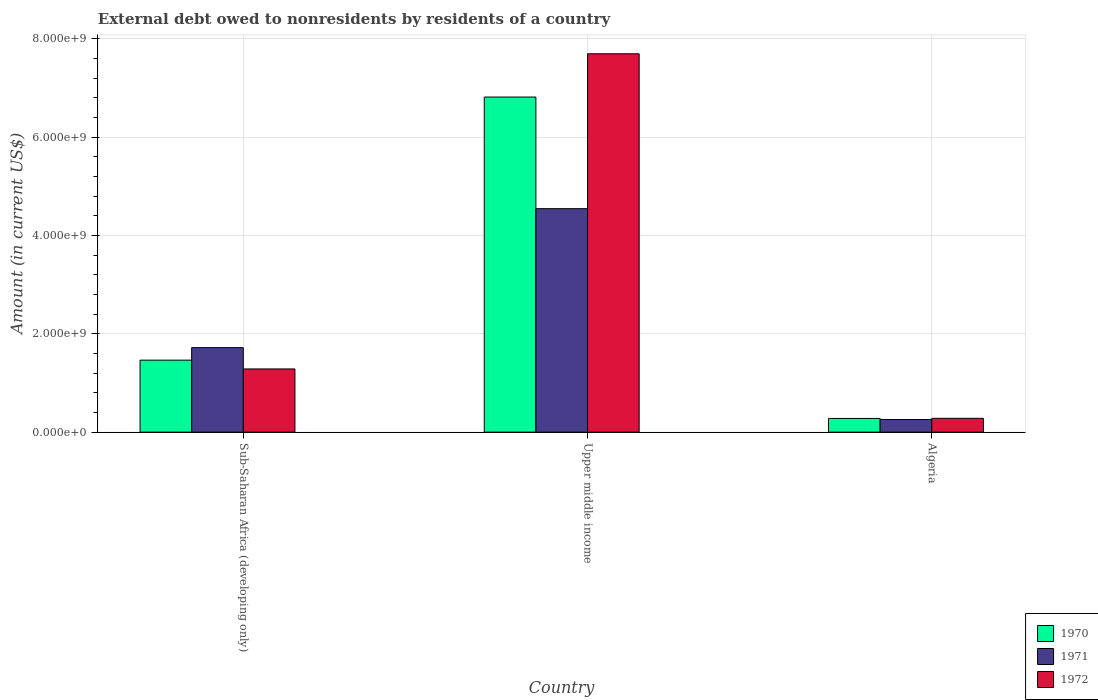How many different coloured bars are there?
Provide a short and direct response. 3. Are the number of bars on each tick of the X-axis equal?
Your answer should be very brief. Yes. What is the label of the 1st group of bars from the left?
Offer a very short reply. Sub-Saharan Africa (developing only). What is the external debt owed by residents in 1970 in Upper middle income?
Make the answer very short. 6.81e+09. Across all countries, what is the maximum external debt owed by residents in 1971?
Ensure brevity in your answer.  4.54e+09. Across all countries, what is the minimum external debt owed by residents in 1971?
Provide a succinct answer. 2.57e+08. In which country was the external debt owed by residents in 1972 maximum?
Offer a terse response. Upper middle income. In which country was the external debt owed by residents in 1972 minimum?
Provide a succinct answer. Algeria. What is the total external debt owed by residents in 1971 in the graph?
Provide a short and direct response. 6.52e+09. What is the difference between the external debt owed by residents in 1972 in Algeria and that in Upper middle income?
Make the answer very short. -7.41e+09. What is the difference between the external debt owed by residents in 1971 in Sub-Saharan Africa (developing only) and the external debt owed by residents in 1970 in Upper middle income?
Your answer should be compact. -5.10e+09. What is the average external debt owed by residents in 1970 per country?
Ensure brevity in your answer.  2.85e+09. What is the difference between the external debt owed by residents of/in 1972 and external debt owed by residents of/in 1970 in Algeria?
Make the answer very short. 2.27e+06. In how many countries, is the external debt owed by residents in 1970 greater than 4400000000 US$?
Keep it short and to the point. 1. What is the ratio of the external debt owed by residents in 1972 in Sub-Saharan Africa (developing only) to that in Upper middle income?
Offer a terse response. 0.17. Is the external debt owed by residents in 1971 in Algeria less than that in Upper middle income?
Provide a succinct answer. Yes. What is the difference between the highest and the second highest external debt owed by residents in 1972?
Make the answer very short. 6.41e+09. What is the difference between the highest and the lowest external debt owed by residents in 1972?
Provide a short and direct response. 7.41e+09. In how many countries, is the external debt owed by residents in 1971 greater than the average external debt owed by residents in 1971 taken over all countries?
Your answer should be very brief. 1. Is the sum of the external debt owed by residents in 1970 in Algeria and Sub-Saharan Africa (developing only) greater than the maximum external debt owed by residents in 1971 across all countries?
Offer a very short reply. No. What does the 2nd bar from the left in Upper middle income represents?
Provide a succinct answer. 1971. What does the 3rd bar from the right in Algeria represents?
Offer a very short reply. 1970. What is the difference between two consecutive major ticks on the Y-axis?
Offer a terse response. 2.00e+09. Are the values on the major ticks of Y-axis written in scientific E-notation?
Offer a very short reply. Yes. Does the graph contain grids?
Provide a short and direct response. Yes. Where does the legend appear in the graph?
Your answer should be compact. Bottom right. How are the legend labels stacked?
Make the answer very short. Vertical. What is the title of the graph?
Your answer should be compact. External debt owed to nonresidents by residents of a country. What is the label or title of the Y-axis?
Your answer should be compact. Amount (in current US$). What is the Amount (in current US$) in 1970 in Sub-Saharan Africa (developing only)?
Your response must be concise. 1.46e+09. What is the Amount (in current US$) in 1971 in Sub-Saharan Africa (developing only)?
Keep it short and to the point. 1.72e+09. What is the Amount (in current US$) in 1972 in Sub-Saharan Africa (developing only)?
Provide a short and direct response. 1.29e+09. What is the Amount (in current US$) of 1970 in Upper middle income?
Your answer should be compact. 6.81e+09. What is the Amount (in current US$) in 1971 in Upper middle income?
Offer a terse response. 4.54e+09. What is the Amount (in current US$) of 1972 in Upper middle income?
Provide a short and direct response. 7.69e+09. What is the Amount (in current US$) of 1970 in Algeria?
Your answer should be very brief. 2.79e+08. What is the Amount (in current US$) of 1971 in Algeria?
Keep it short and to the point. 2.57e+08. What is the Amount (in current US$) in 1972 in Algeria?
Your answer should be very brief. 2.81e+08. Across all countries, what is the maximum Amount (in current US$) in 1970?
Provide a short and direct response. 6.81e+09. Across all countries, what is the maximum Amount (in current US$) of 1971?
Keep it short and to the point. 4.54e+09. Across all countries, what is the maximum Amount (in current US$) in 1972?
Give a very brief answer. 7.69e+09. Across all countries, what is the minimum Amount (in current US$) in 1970?
Make the answer very short. 2.79e+08. Across all countries, what is the minimum Amount (in current US$) in 1971?
Your answer should be very brief. 2.57e+08. Across all countries, what is the minimum Amount (in current US$) of 1972?
Offer a terse response. 2.81e+08. What is the total Amount (in current US$) of 1970 in the graph?
Keep it short and to the point. 8.56e+09. What is the total Amount (in current US$) of 1971 in the graph?
Your answer should be very brief. 6.52e+09. What is the total Amount (in current US$) in 1972 in the graph?
Keep it short and to the point. 9.26e+09. What is the difference between the Amount (in current US$) of 1970 in Sub-Saharan Africa (developing only) and that in Upper middle income?
Give a very brief answer. -5.35e+09. What is the difference between the Amount (in current US$) of 1971 in Sub-Saharan Africa (developing only) and that in Upper middle income?
Your answer should be compact. -2.83e+09. What is the difference between the Amount (in current US$) in 1972 in Sub-Saharan Africa (developing only) and that in Upper middle income?
Give a very brief answer. -6.41e+09. What is the difference between the Amount (in current US$) of 1970 in Sub-Saharan Africa (developing only) and that in Algeria?
Provide a short and direct response. 1.19e+09. What is the difference between the Amount (in current US$) in 1971 in Sub-Saharan Africa (developing only) and that in Algeria?
Provide a succinct answer. 1.46e+09. What is the difference between the Amount (in current US$) in 1972 in Sub-Saharan Africa (developing only) and that in Algeria?
Your response must be concise. 1.00e+09. What is the difference between the Amount (in current US$) of 1970 in Upper middle income and that in Algeria?
Your answer should be compact. 6.54e+09. What is the difference between the Amount (in current US$) in 1971 in Upper middle income and that in Algeria?
Your answer should be very brief. 4.29e+09. What is the difference between the Amount (in current US$) in 1972 in Upper middle income and that in Algeria?
Keep it short and to the point. 7.41e+09. What is the difference between the Amount (in current US$) in 1970 in Sub-Saharan Africa (developing only) and the Amount (in current US$) in 1971 in Upper middle income?
Provide a short and direct response. -3.08e+09. What is the difference between the Amount (in current US$) in 1970 in Sub-Saharan Africa (developing only) and the Amount (in current US$) in 1972 in Upper middle income?
Give a very brief answer. -6.23e+09. What is the difference between the Amount (in current US$) in 1971 in Sub-Saharan Africa (developing only) and the Amount (in current US$) in 1972 in Upper middle income?
Your answer should be compact. -5.98e+09. What is the difference between the Amount (in current US$) in 1970 in Sub-Saharan Africa (developing only) and the Amount (in current US$) in 1971 in Algeria?
Your answer should be very brief. 1.21e+09. What is the difference between the Amount (in current US$) of 1970 in Sub-Saharan Africa (developing only) and the Amount (in current US$) of 1972 in Algeria?
Provide a short and direct response. 1.18e+09. What is the difference between the Amount (in current US$) of 1971 in Sub-Saharan Africa (developing only) and the Amount (in current US$) of 1972 in Algeria?
Offer a terse response. 1.44e+09. What is the difference between the Amount (in current US$) in 1970 in Upper middle income and the Amount (in current US$) in 1971 in Algeria?
Your answer should be very brief. 6.56e+09. What is the difference between the Amount (in current US$) of 1970 in Upper middle income and the Amount (in current US$) of 1972 in Algeria?
Give a very brief answer. 6.53e+09. What is the difference between the Amount (in current US$) in 1971 in Upper middle income and the Amount (in current US$) in 1972 in Algeria?
Keep it short and to the point. 4.26e+09. What is the average Amount (in current US$) in 1970 per country?
Ensure brevity in your answer.  2.85e+09. What is the average Amount (in current US$) in 1971 per country?
Keep it short and to the point. 2.17e+09. What is the average Amount (in current US$) of 1972 per country?
Keep it short and to the point. 3.09e+09. What is the difference between the Amount (in current US$) of 1970 and Amount (in current US$) of 1971 in Sub-Saharan Africa (developing only)?
Make the answer very short. -2.55e+08. What is the difference between the Amount (in current US$) of 1970 and Amount (in current US$) of 1972 in Sub-Saharan Africa (developing only)?
Ensure brevity in your answer.  1.79e+08. What is the difference between the Amount (in current US$) in 1971 and Amount (in current US$) in 1972 in Sub-Saharan Africa (developing only)?
Your response must be concise. 4.33e+08. What is the difference between the Amount (in current US$) in 1970 and Amount (in current US$) in 1971 in Upper middle income?
Ensure brevity in your answer.  2.27e+09. What is the difference between the Amount (in current US$) in 1970 and Amount (in current US$) in 1972 in Upper middle income?
Your response must be concise. -8.80e+08. What is the difference between the Amount (in current US$) in 1971 and Amount (in current US$) in 1972 in Upper middle income?
Your response must be concise. -3.15e+09. What is the difference between the Amount (in current US$) in 1970 and Amount (in current US$) in 1971 in Algeria?
Ensure brevity in your answer.  2.18e+07. What is the difference between the Amount (in current US$) in 1970 and Amount (in current US$) in 1972 in Algeria?
Offer a very short reply. -2.27e+06. What is the difference between the Amount (in current US$) in 1971 and Amount (in current US$) in 1972 in Algeria?
Your answer should be very brief. -2.41e+07. What is the ratio of the Amount (in current US$) in 1970 in Sub-Saharan Africa (developing only) to that in Upper middle income?
Offer a terse response. 0.21. What is the ratio of the Amount (in current US$) of 1971 in Sub-Saharan Africa (developing only) to that in Upper middle income?
Offer a terse response. 0.38. What is the ratio of the Amount (in current US$) in 1972 in Sub-Saharan Africa (developing only) to that in Upper middle income?
Your answer should be very brief. 0.17. What is the ratio of the Amount (in current US$) in 1970 in Sub-Saharan Africa (developing only) to that in Algeria?
Provide a short and direct response. 5.25. What is the ratio of the Amount (in current US$) of 1971 in Sub-Saharan Africa (developing only) to that in Algeria?
Provide a succinct answer. 6.69. What is the ratio of the Amount (in current US$) of 1972 in Sub-Saharan Africa (developing only) to that in Algeria?
Provide a succinct answer. 4.57. What is the ratio of the Amount (in current US$) in 1970 in Upper middle income to that in Algeria?
Keep it short and to the point. 24.45. What is the ratio of the Amount (in current US$) of 1971 in Upper middle income to that in Algeria?
Ensure brevity in your answer.  17.68. What is the ratio of the Amount (in current US$) in 1972 in Upper middle income to that in Algeria?
Keep it short and to the point. 27.38. What is the difference between the highest and the second highest Amount (in current US$) of 1970?
Your response must be concise. 5.35e+09. What is the difference between the highest and the second highest Amount (in current US$) of 1971?
Your answer should be very brief. 2.83e+09. What is the difference between the highest and the second highest Amount (in current US$) in 1972?
Provide a succinct answer. 6.41e+09. What is the difference between the highest and the lowest Amount (in current US$) in 1970?
Offer a terse response. 6.54e+09. What is the difference between the highest and the lowest Amount (in current US$) of 1971?
Offer a terse response. 4.29e+09. What is the difference between the highest and the lowest Amount (in current US$) in 1972?
Your answer should be very brief. 7.41e+09. 